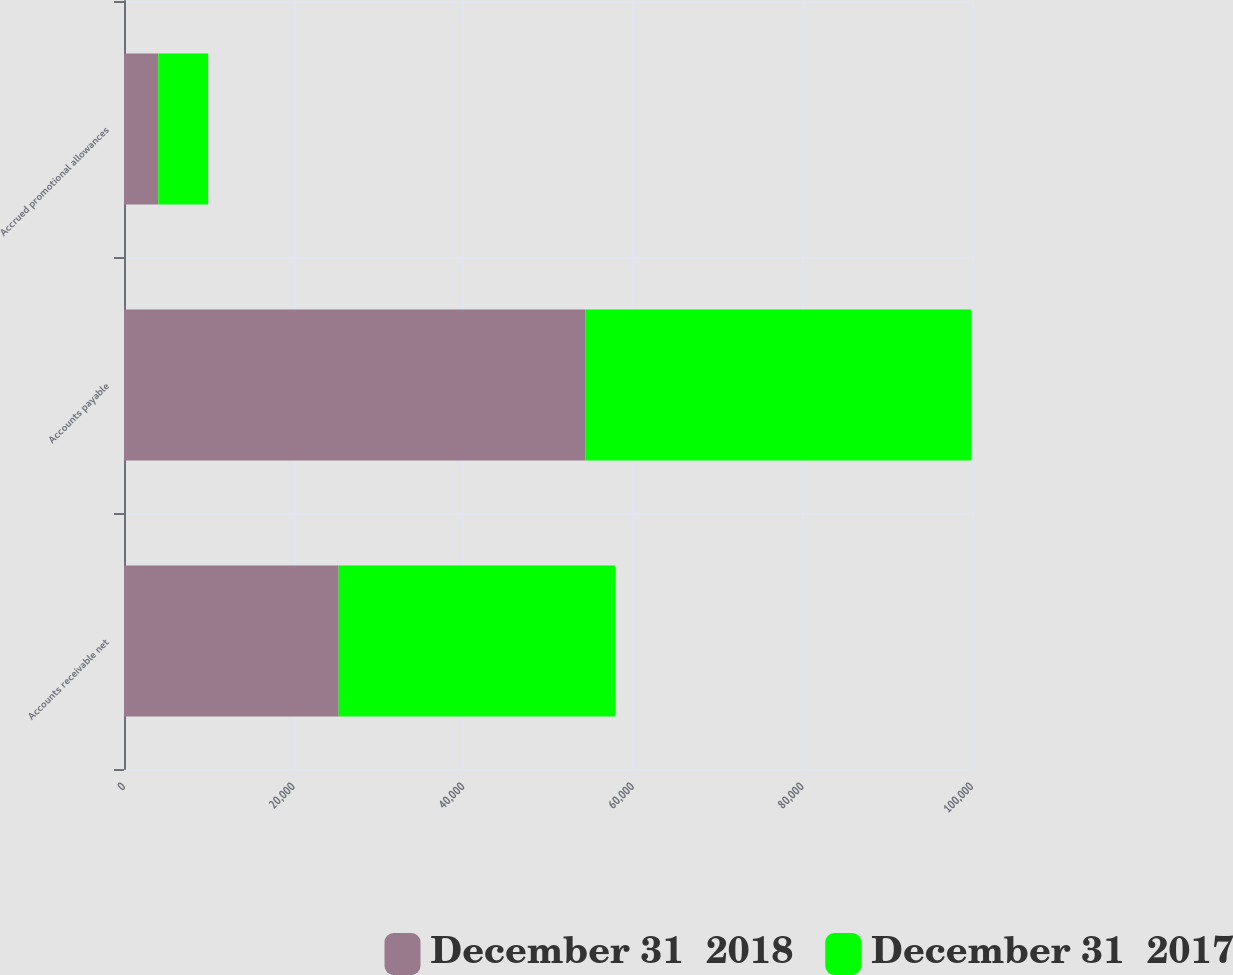Convert chart to OTSL. <chart><loc_0><loc_0><loc_500><loc_500><stacked_bar_chart><ecel><fcel>Accounts receivable net<fcel>Accounts payable<fcel>Accrued promotional allowances<nl><fcel>December 31  2018<fcel>25312<fcel>54430<fcel>4044<nl><fcel>December 31  2017<fcel>32607<fcel>45465<fcel>5884<nl></chart> 